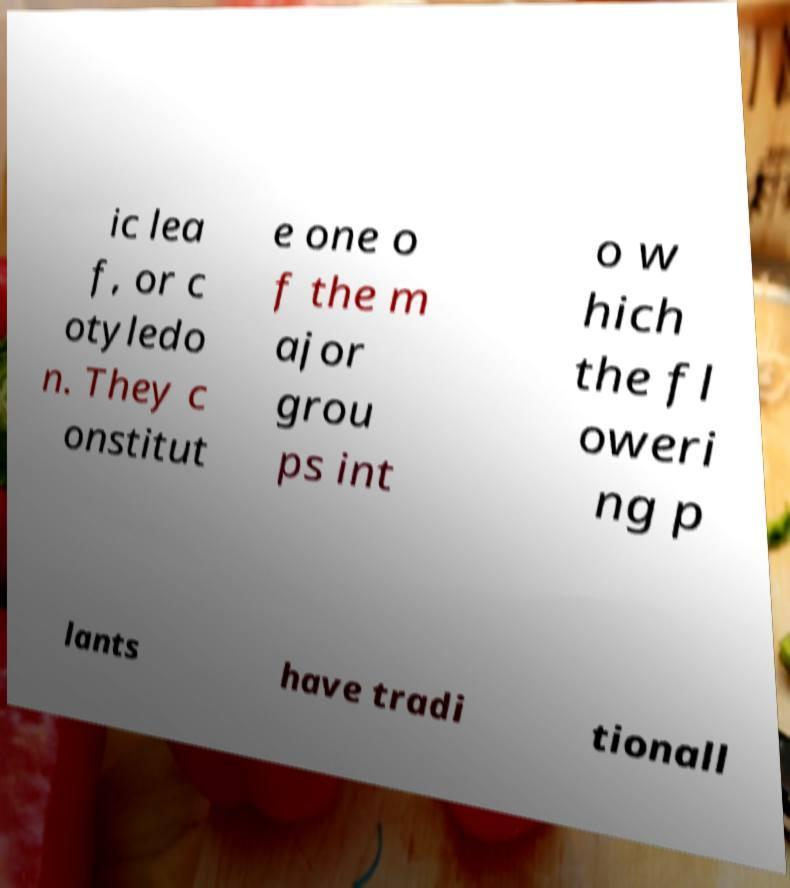Could you assist in decoding the text presented in this image and type it out clearly? ic lea f, or c otyledo n. They c onstitut e one o f the m ajor grou ps int o w hich the fl oweri ng p lants have tradi tionall 